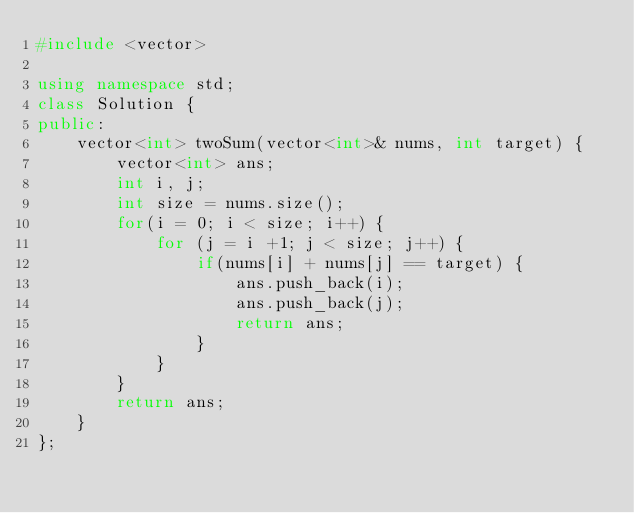Convert code to text. <code><loc_0><loc_0><loc_500><loc_500><_C++_>#include <vector>

using namespace std;
class Solution {
public:
    vector<int> twoSum(vector<int>& nums, int target) {
        vector<int> ans;
        int i, j;
        int size = nums.size();
        for(i = 0; i < size; i++) {
            for (j = i +1; j < size; j++) {
                if(nums[i] + nums[j] == target) {
                    ans.push_back(i);
                    ans.push_back(j);
                    return ans;
                }
            }
        }
        return ans;
    }
};
</code> 